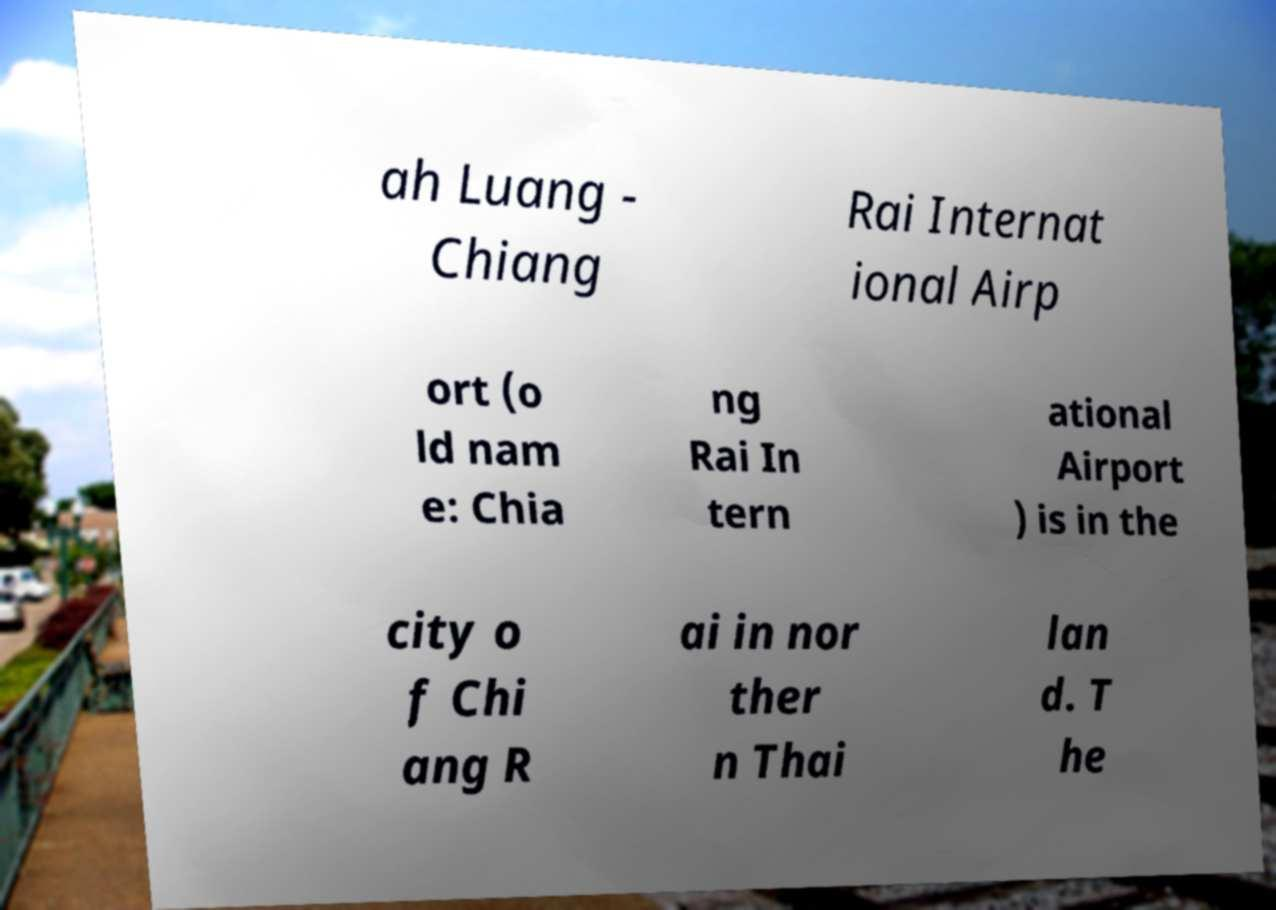Please read and relay the text visible in this image. What does it say? ah Luang - Chiang Rai Internat ional Airp ort (o ld nam e: Chia ng Rai In tern ational Airport ) is in the city o f Chi ang R ai in nor ther n Thai lan d. T he 